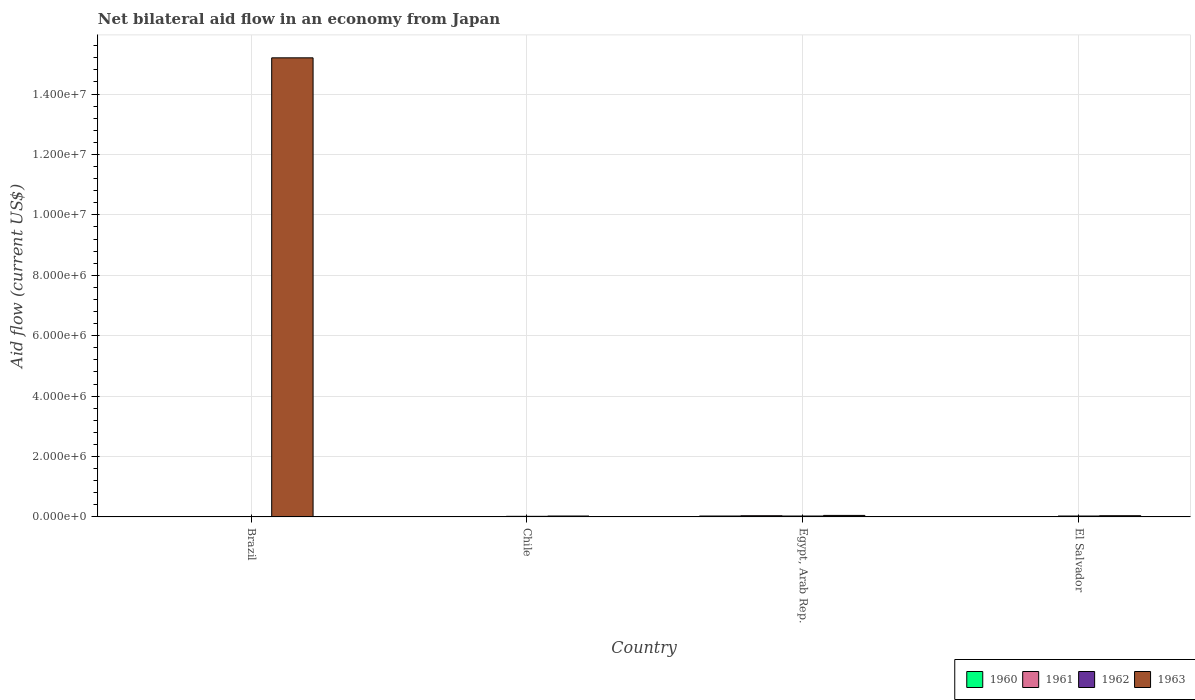How many different coloured bars are there?
Your answer should be compact. 4. Are the number of bars per tick equal to the number of legend labels?
Your response must be concise. No. What is the label of the 3rd group of bars from the left?
Keep it short and to the point. Egypt, Arab Rep. What is the net bilateral aid flow in 1960 in El Salvador?
Keep it short and to the point. 10000. Across all countries, what is the maximum net bilateral aid flow in 1962?
Make the answer very short. 3.00e+04. Across all countries, what is the minimum net bilateral aid flow in 1962?
Your response must be concise. 0. In which country was the net bilateral aid flow in 1962 maximum?
Your answer should be compact. Egypt, Arab Rep. What is the total net bilateral aid flow in 1963 in the graph?
Offer a very short reply. 1.53e+07. What is the average net bilateral aid flow in 1963 per country?
Keep it short and to the point. 3.83e+06. In how many countries, is the net bilateral aid flow in 1962 greater than 9200000 US$?
Your answer should be compact. 0. Is the net bilateral aid flow in 1963 in Brazil less than that in El Salvador?
Your response must be concise. No. What is the difference between the highest and the second highest net bilateral aid flow in 1962?
Keep it short and to the point. 10000. In how many countries, is the net bilateral aid flow in 1961 greater than the average net bilateral aid flow in 1961 taken over all countries?
Your answer should be compact. 1. Is it the case that in every country, the sum of the net bilateral aid flow in 1962 and net bilateral aid flow in 1963 is greater than the sum of net bilateral aid flow in 1960 and net bilateral aid flow in 1961?
Offer a very short reply. No. Are the values on the major ticks of Y-axis written in scientific E-notation?
Your response must be concise. Yes. Where does the legend appear in the graph?
Keep it short and to the point. Bottom right. How many legend labels are there?
Provide a succinct answer. 4. What is the title of the graph?
Provide a succinct answer. Net bilateral aid flow in an economy from Japan. Does "1990" appear as one of the legend labels in the graph?
Make the answer very short. No. What is the label or title of the X-axis?
Keep it short and to the point. Country. What is the Aid flow (current US$) in 1962 in Brazil?
Offer a very short reply. 0. What is the Aid flow (current US$) in 1963 in Brazil?
Ensure brevity in your answer.  1.52e+07. What is the Aid flow (current US$) in 1961 in Chile?
Your answer should be very brief. 10000. What is the Aid flow (current US$) in 1962 in Chile?
Provide a succinct answer. 2.00e+04. What is the Aid flow (current US$) of 1963 in Chile?
Provide a short and direct response. 3.00e+04. What is the Aid flow (current US$) in 1961 in El Salvador?
Provide a succinct answer. 10000. What is the Aid flow (current US$) in 1962 in El Salvador?
Provide a succinct answer. 3.00e+04. Across all countries, what is the maximum Aid flow (current US$) in 1963?
Offer a terse response. 1.52e+07. Across all countries, what is the minimum Aid flow (current US$) in 1960?
Offer a very short reply. 0. Across all countries, what is the minimum Aid flow (current US$) of 1962?
Ensure brevity in your answer.  0. Across all countries, what is the minimum Aid flow (current US$) of 1963?
Your response must be concise. 3.00e+04. What is the total Aid flow (current US$) of 1960 in the graph?
Offer a terse response. 5.00e+04. What is the total Aid flow (current US$) in 1963 in the graph?
Your answer should be very brief. 1.53e+07. What is the difference between the Aid flow (current US$) in 1963 in Brazil and that in Chile?
Your response must be concise. 1.52e+07. What is the difference between the Aid flow (current US$) of 1963 in Brazil and that in Egypt, Arab Rep.?
Make the answer very short. 1.52e+07. What is the difference between the Aid flow (current US$) of 1963 in Brazil and that in El Salvador?
Give a very brief answer. 1.52e+07. What is the difference between the Aid flow (current US$) in 1962 in Chile and that in El Salvador?
Make the answer very short. -10000. What is the difference between the Aid flow (current US$) in 1960 in Egypt, Arab Rep. and that in El Salvador?
Give a very brief answer. 2.00e+04. What is the difference between the Aid flow (current US$) of 1961 in Egypt, Arab Rep. and that in El Salvador?
Your response must be concise. 3.00e+04. What is the difference between the Aid flow (current US$) of 1962 in Egypt, Arab Rep. and that in El Salvador?
Your response must be concise. 0. What is the difference between the Aid flow (current US$) of 1963 in Egypt, Arab Rep. and that in El Salvador?
Your answer should be compact. 10000. What is the difference between the Aid flow (current US$) of 1960 in Chile and the Aid flow (current US$) of 1961 in Egypt, Arab Rep.?
Your answer should be very brief. -3.00e+04. What is the difference between the Aid flow (current US$) of 1960 in Chile and the Aid flow (current US$) of 1963 in Egypt, Arab Rep.?
Give a very brief answer. -4.00e+04. What is the difference between the Aid flow (current US$) of 1961 in Chile and the Aid flow (current US$) of 1962 in Egypt, Arab Rep.?
Make the answer very short. -2.00e+04. What is the difference between the Aid flow (current US$) in 1961 in Chile and the Aid flow (current US$) in 1963 in Egypt, Arab Rep.?
Offer a terse response. -4.00e+04. What is the difference between the Aid flow (current US$) in 1962 in Chile and the Aid flow (current US$) in 1963 in Egypt, Arab Rep.?
Keep it short and to the point. -3.00e+04. What is the difference between the Aid flow (current US$) of 1960 in Chile and the Aid flow (current US$) of 1961 in El Salvador?
Offer a terse response. 0. What is the difference between the Aid flow (current US$) in 1960 in Chile and the Aid flow (current US$) in 1962 in El Salvador?
Ensure brevity in your answer.  -2.00e+04. What is the difference between the Aid flow (current US$) in 1961 in Chile and the Aid flow (current US$) in 1962 in El Salvador?
Provide a short and direct response. -2.00e+04. What is the difference between the Aid flow (current US$) in 1961 in Chile and the Aid flow (current US$) in 1963 in El Salvador?
Your response must be concise. -3.00e+04. What is the difference between the Aid flow (current US$) in 1962 in Chile and the Aid flow (current US$) in 1963 in El Salvador?
Ensure brevity in your answer.  -2.00e+04. What is the difference between the Aid flow (current US$) in 1961 in Egypt, Arab Rep. and the Aid flow (current US$) in 1962 in El Salvador?
Provide a short and direct response. 10000. What is the difference between the Aid flow (current US$) of 1961 in Egypt, Arab Rep. and the Aid flow (current US$) of 1963 in El Salvador?
Offer a very short reply. 0. What is the average Aid flow (current US$) of 1960 per country?
Ensure brevity in your answer.  1.25e+04. What is the average Aid flow (current US$) of 1961 per country?
Provide a short and direct response. 1.50e+04. What is the average Aid flow (current US$) in 1963 per country?
Your answer should be very brief. 3.83e+06. What is the difference between the Aid flow (current US$) of 1960 and Aid flow (current US$) of 1962 in Chile?
Your answer should be compact. -10000. What is the difference between the Aid flow (current US$) in 1960 and Aid flow (current US$) in 1963 in Chile?
Keep it short and to the point. -2.00e+04. What is the difference between the Aid flow (current US$) in 1962 and Aid flow (current US$) in 1963 in Chile?
Provide a succinct answer. -10000. What is the difference between the Aid flow (current US$) of 1960 and Aid flow (current US$) of 1962 in Egypt, Arab Rep.?
Give a very brief answer. 0. What is the difference between the Aid flow (current US$) in 1961 and Aid flow (current US$) in 1963 in Egypt, Arab Rep.?
Ensure brevity in your answer.  -10000. What is the difference between the Aid flow (current US$) of 1962 and Aid flow (current US$) of 1963 in Egypt, Arab Rep.?
Provide a succinct answer. -2.00e+04. What is the difference between the Aid flow (current US$) of 1961 and Aid flow (current US$) of 1962 in El Salvador?
Ensure brevity in your answer.  -2.00e+04. What is the difference between the Aid flow (current US$) in 1961 and Aid flow (current US$) in 1963 in El Salvador?
Your response must be concise. -3.00e+04. What is the ratio of the Aid flow (current US$) of 1963 in Brazil to that in Chile?
Your answer should be compact. 506.67. What is the ratio of the Aid flow (current US$) in 1963 in Brazil to that in Egypt, Arab Rep.?
Offer a very short reply. 304. What is the ratio of the Aid flow (current US$) of 1963 in Brazil to that in El Salvador?
Provide a succinct answer. 380. What is the ratio of the Aid flow (current US$) in 1961 in Chile to that in El Salvador?
Provide a succinct answer. 1. What is the ratio of the Aid flow (current US$) of 1963 in Chile to that in El Salvador?
Ensure brevity in your answer.  0.75. What is the ratio of the Aid flow (current US$) of 1961 in Egypt, Arab Rep. to that in El Salvador?
Your answer should be very brief. 4. What is the ratio of the Aid flow (current US$) in 1963 in Egypt, Arab Rep. to that in El Salvador?
Offer a terse response. 1.25. What is the difference between the highest and the second highest Aid flow (current US$) in 1960?
Provide a short and direct response. 2.00e+04. What is the difference between the highest and the second highest Aid flow (current US$) of 1962?
Keep it short and to the point. 0. What is the difference between the highest and the second highest Aid flow (current US$) in 1963?
Make the answer very short. 1.52e+07. What is the difference between the highest and the lowest Aid flow (current US$) of 1961?
Your response must be concise. 4.00e+04. What is the difference between the highest and the lowest Aid flow (current US$) in 1963?
Your response must be concise. 1.52e+07. 